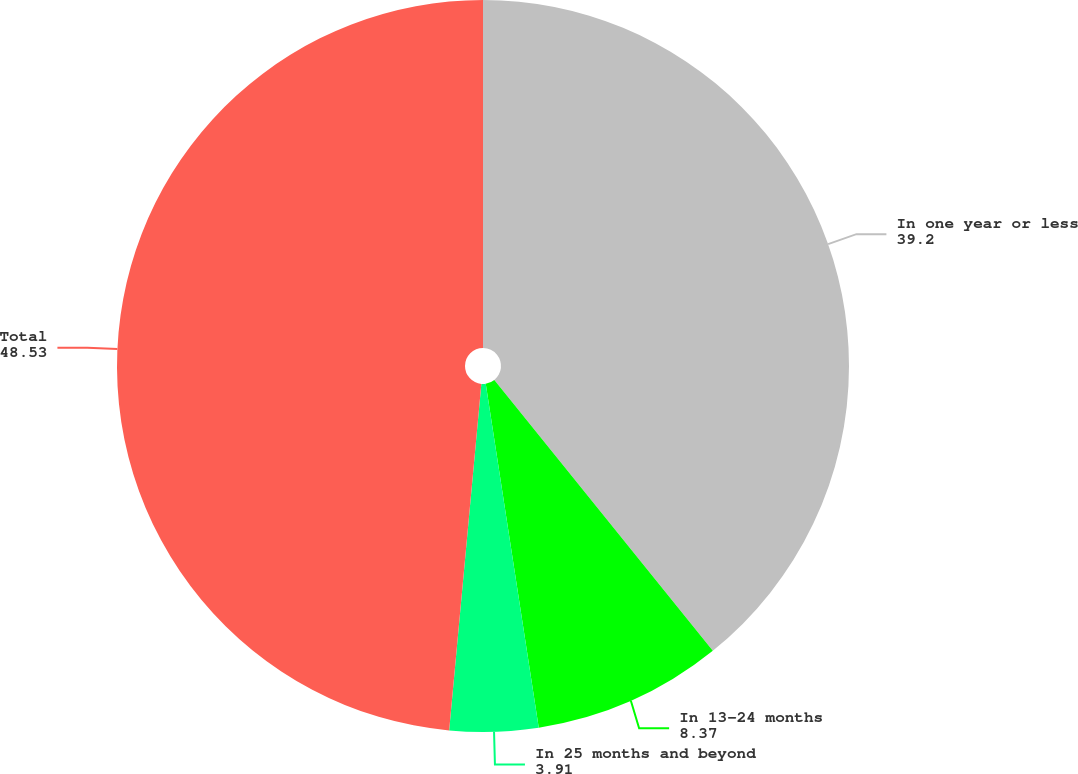Convert chart to OTSL. <chart><loc_0><loc_0><loc_500><loc_500><pie_chart><fcel>In one year or less<fcel>In 13-24 months<fcel>In 25 months and beyond<fcel>Total<nl><fcel>39.2%<fcel>8.37%<fcel>3.91%<fcel>48.53%<nl></chart> 